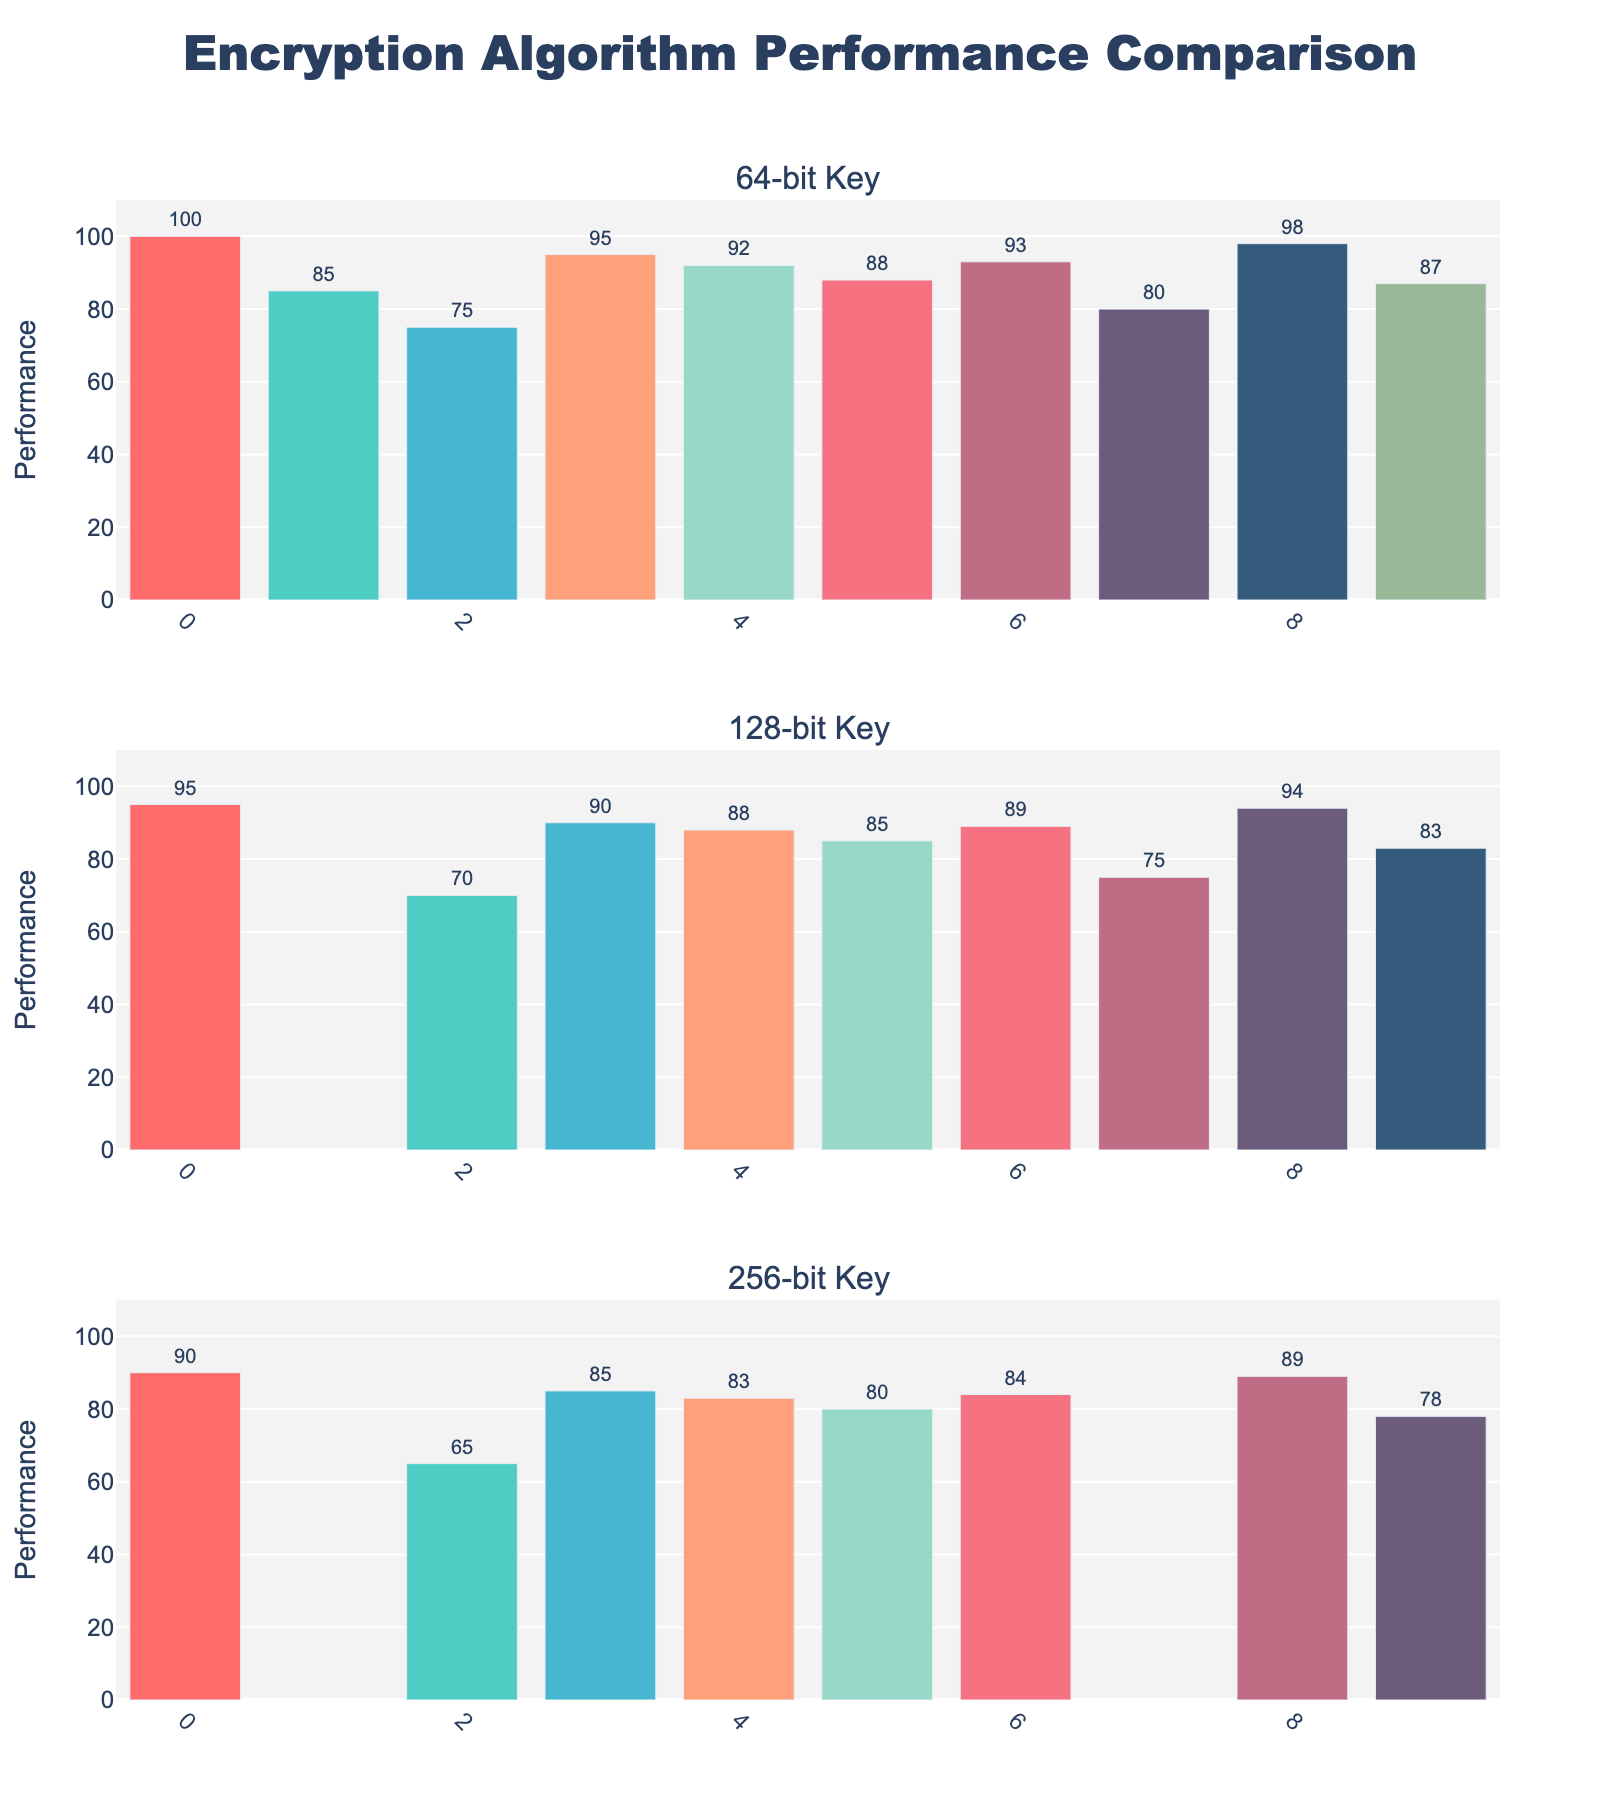Which algorithm has the highest performance for the 256-bit key size? Look at the performance values for the 256-bit key size subplot. Camellia has the highest value at 89.
Answer: Camellia How does the performance of AES change with increasing key size? In each subplot for 64-bit, 128-bit, and 256-bit key sizes, observe the performance values of AES: 100 for 64-bit, 95 for 128-bit, and 90 for 256-bit. It decreases step by step.
Answer: Decreases What is the average performance of Blowfish across all key sizes? Look at the performance values for Blowfish in each subplot: 95 for 64-bit, 90 for 128-bit, and 85 for 256-bit. Calculate the average as (95 + 90 + 85) / 3 = 90.
Answer: 90 Is the performance of Serpent better than IDEA for the 128-bit key size? Check the performance values in the 128-bit key size subplot. Serpent scores 85, while IDEA scores 75. Thus, Serpent has a higher value.
Answer: Yes Which algorithm has the lowest performance for the 64-bit key size? Look at the performance values for the 64-bit key size subplot. 3DES has the lowest value at 75.
Answer: 3DES What is the difference in performance between DES and 3DES for the 64-bit key size? Identify the values of DES and 3DES for 64-bit from the first subplot: DES is 85, and 3DES is 75. The difference is 85 - 75 = 10.
Answer: 10 How many algorithms have performance data for the 256-bit key size? Count the bars shown in the 256-bit key size subplot. The bars are for AES, 3DES, Blowfish, Twofish, Serpent, RC6, and Camellia. There are 7 algorithms.
Answer: 7 Do all algorithms have data for the 128-bit key size? Look at the bars in the 128-bit key size subplot. DES and IDEA are missing for this key size, indicating not all algorithms have data.
Answer: No Which key size shows the highest performance for RC6? Compare the performance values in each subplot for RC6: 93 for 64-bit, 89 for 128-bit, and 84 for 256-bit. The highest value is 93 for the 64-bit key size.
Answer: 64-bit What is the total performance sum of Camellia across all key sizes? Add up the performance values of Camellia from each subplot: 98 for 64-bit, 94 for 128-bit, and 89 for 256-bit. The sum is 98 + 94 + 89 = 281.
Answer: 281 